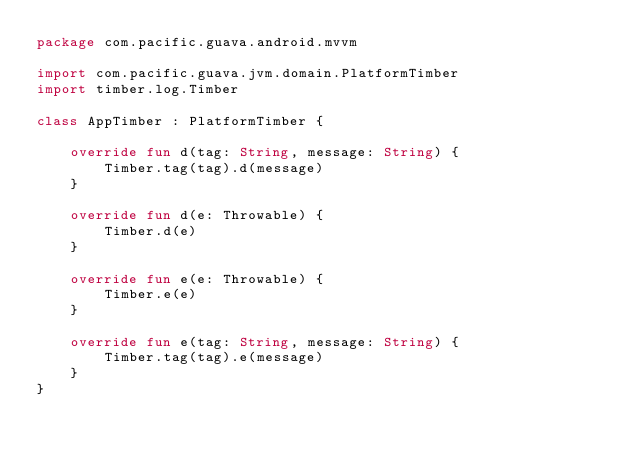Convert code to text. <code><loc_0><loc_0><loc_500><loc_500><_Kotlin_>package com.pacific.guava.android.mvvm

import com.pacific.guava.jvm.domain.PlatformTimber
import timber.log.Timber

class AppTimber : PlatformTimber {

    override fun d(tag: String, message: String) {
        Timber.tag(tag).d(message)
    }

    override fun d(e: Throwable) {
        Timber.d(e)
    }

    override fun e(e: Throwable) {
        Timber.e(e)
    }

    override fun e(tag: String, message: String) {
        Timber.tag(tag).e(message)
    }
}</code> 